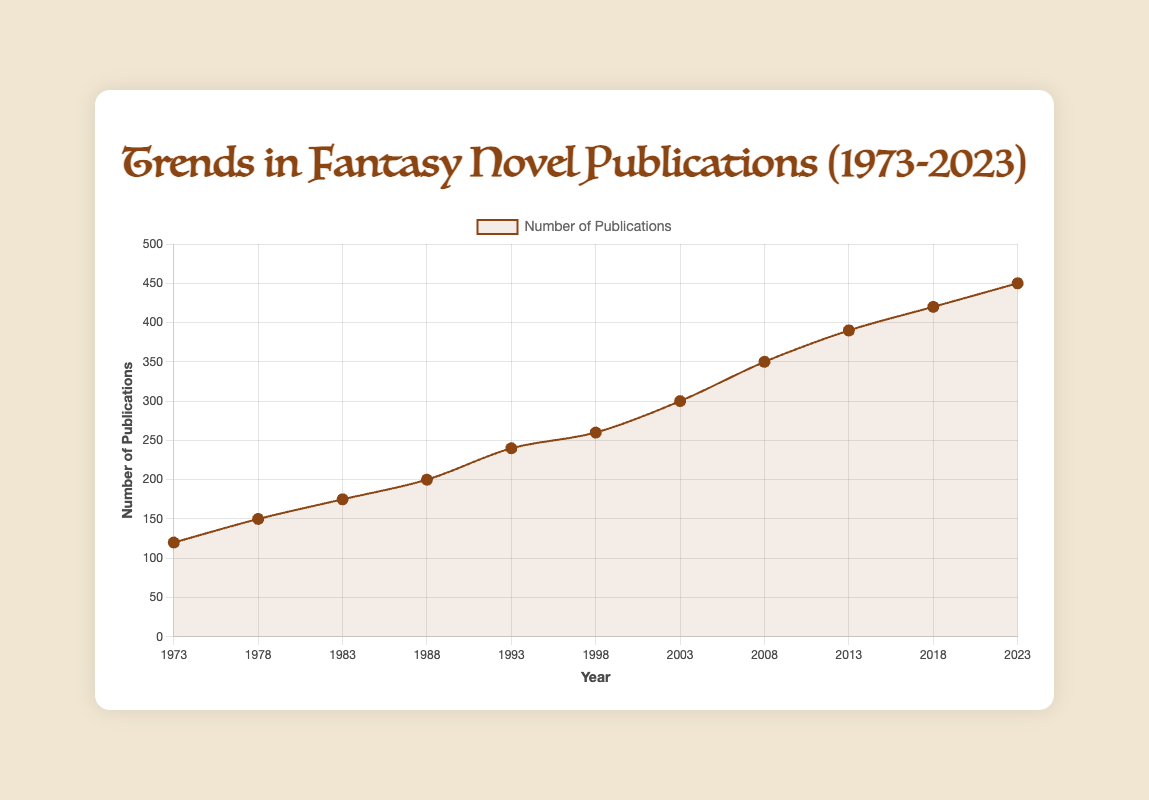What is the range of the number of publications from 1973 to 2023? The range is the difference between the maximum and minimum values. Here, the maximum number of publications is 450 (in 2023), and the minimum is 120 (in 1973). The range is 450 - 120 = 330.
Answer: 330 By how much did the number of publications increase from 1978 to 1988? Look at the number of publications in 1978 (150) and 1988 (200). The increase is 200 - 150 = 50.
Answer: 50 Which year had the greatest increase in the number of publications compared to the previous recorded year? Calculate the differences between consecutive years: 1978-1973 (150-120 = 30), 1983-1978 (175-150 = 25), 1988-1983 (200-175 = 25), 1993-1988 (240-200 = 40), 1998-1993 (260-240 = 20), 2003-1998 (300-260 = 40), 2008-2003 (350-300 = 50), 2013-2008 (390-350 = 40), 2018-2013 (420-390 = 30), and 2023-2018 (450-420 = 30). The greatest increase is in 2008 (50).
Answer: 2008 What is the median number of publications for the years provided? List the number of publications for each year in ascending order: 120, 150, 175, 200, 240, 260, 300, 350, 390, 420, 450. With 11 data points, the median is the 6th value, which is 260.
Answer: 260 Compare the number of publications in 1993 and 2018. Which year had more, and by how much? In 1993, there were 240 publications, and in 2018 there were 420. 2018 had more publications. The difference is 420 - 240 = 180.
Answer: 2018, 180 How many years did it take for the number of publications to increase from 300 to 450? The number of publications was 300 in 2003 and 450 in 2023. The difference between 2023 and 2003 is 20 years.
Answer: 20 What was the average number of publications per year from 1973 to 2023? Sum the number of publications: 120 + 150 + 175 + 200 + 240 + 260 + 300 + 350 + 390 + 420 + 450 = 3055. There are 11 values, so the average is 3055 / 11 = 277.
Answer: 277 From which year to which year did the number of publications remain constant or decrease? Compare consecutive years: The count increases every year from 1973 to 2023. There are no constant or decreasing intervals.
Answer: No such years What visual trend do you notice in the number of publications over the 50-year period? The general visual trend is an increase in the number of publications from 120 in 1973 to 450 in 2023, with steady growth and some years of more significant increases.
Answer: Steady growth 